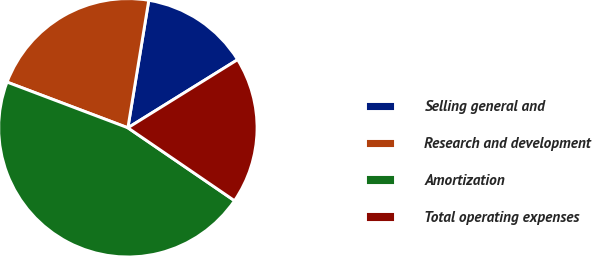<chart> <loc_0><loc_0><loc_500><loc_500><pie_chart><fcel>Selling general and<fcel>Research and development<fcel>Amortization<fcel>Total operating expenses<nl><fcel>13.57%<fcel>21.83%<fcel>46.21%<fcel>18.39%<nl></chart> 